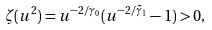Convert formula to latex. <formula><loc_0><loc_0><loc_500><loc_500>\zeta ( u ^ { 2 } ) = u ^ { - 2 / { \gamma } _ { 0 } } ( u ^ { - 2 / \tilde { \gamma } _ { 1 } } - 1 ) > 0 ,</formula> 